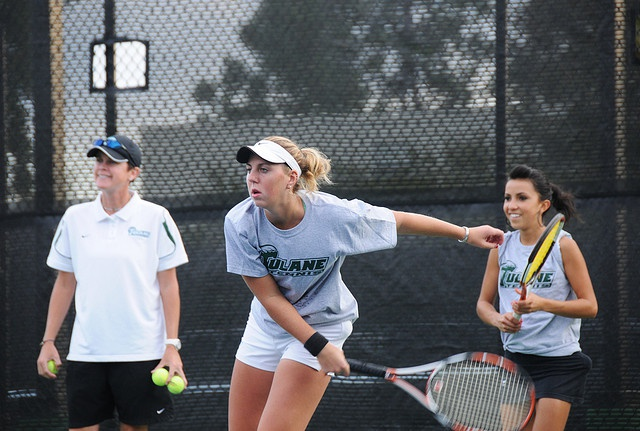Describe the objects in this image and their specific colors. I can see people in black, brown, lavender, and darkgray tones, people in black, lavender, lightpink, and darkgray tones, people in black, brown, and darkgray tones, tennis racket in black, gray, darkgray, and brown tones, and tennis racket in black, darkgray, khaki, and gold tones in this image. 